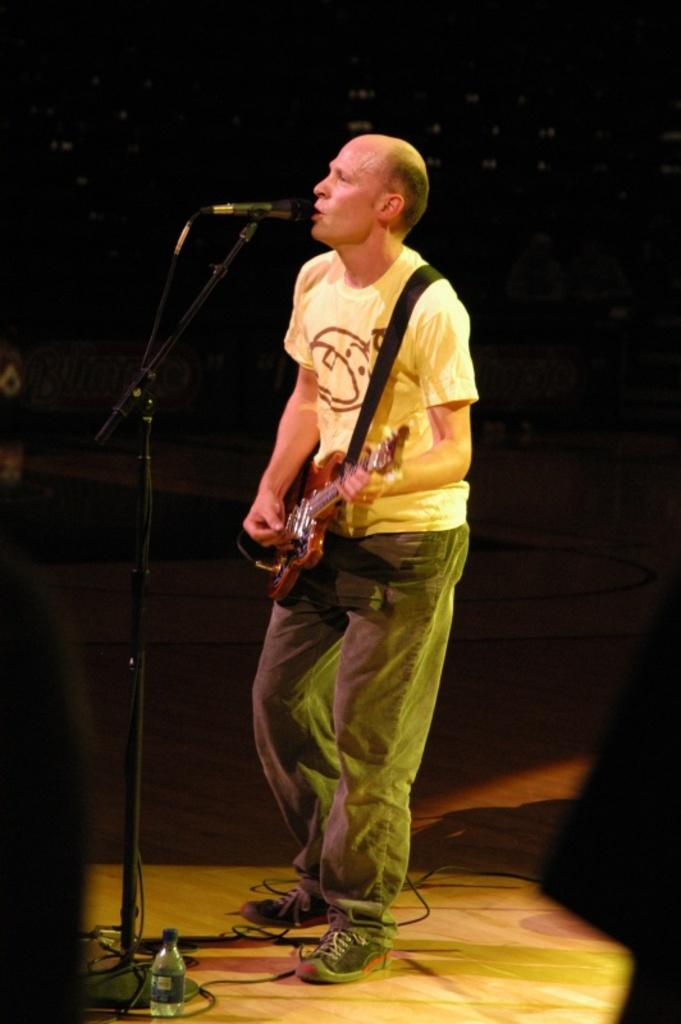What is the man in the image doing? The man is playing a guitar and standing in front of a microphone. What objects are on the floor in the image? There is a bottle, a stand, and wires on the floor. What is the lighting condition in the image? The background of the image is dark. Can you see any cattle or bears in the image? No, there are no cattle or bears present in the image. Is the man playing the guitar in a field? The provided facts do not mention a field, so we cannot determine if the man is playing the guitar in a field. 